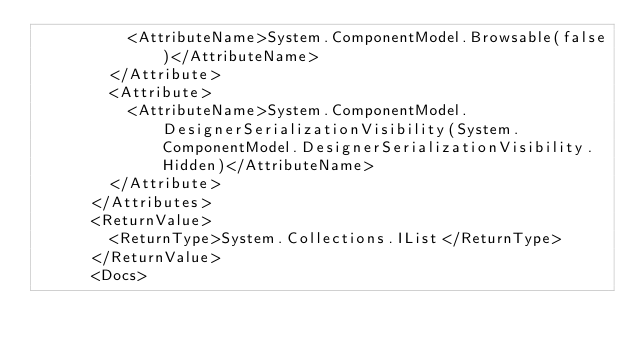<code> <loc_0><loc_0><loc_500><loc_500><_XML_>          <AttributeName>System.ComponentModel.Browsable(false)</AttributeName>
        </Attribute>
        <Attribute>
          <AttributeName>System.ComponentModel.DesignerSerializationVisibility(System.ComponentModel.DesignerSerializationVisibility.Hidden)</AttributeName>
        </Attribute>
      </Attributes>
      <ReturnValue>
        <ReturnType>System.Collections.IList</ReturnType>
      </ReturnValue>
      <Docs></code> 